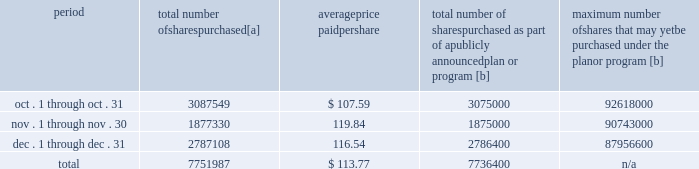Five-year performance comparison 2013 the following graph provides an indicator of cumulative total shareholder returns for the corporation as compared to the peer group index ( described above ) , the dj trans , and the s&p 500 .
The graph assumes that $ 100 was invested in the common stock of union pacific corporation and each index on december 31 , 2009 and that all dividends were reinvested .
The information below is historical in nature and is not necessarily indicative of future performance .
Purchases of equity securities 2013 during 2014 , we repurchased 33035204 shares of our common stock at an average price of $ 100.24 .
The table presents common stock repurchases during each month for the fourth quarter of 2014 : period total number of shares purchased [a] average price paid per share total number of shares purchased as part of a publicly announced plan or program [b] maximum number of shares that may yet be purchased under the plan or program [b] .
[a] total number of shares purchased during the quarter includes approximately 15587 shares delivered or attested to upc by employees to pay stock option exercise prices , satisfy excess tax withholding obligations for stock option exercises or vesting of retention units , and pay withholding obligations for vesting of retention shares .
[b] effective january 1 , 2014 , our board of directors authorized the repurchase of up to 120 million shares of our common stock by december 31 , 2017 .
These repurchases may be made on the open market or through other transactions .
Our management has sole discretion with respect to determining the timing and amount of these transactions. .
What percent of the share repurchases were in the fourth quarter? 
Computations: (7751987 / 33035204)
Answer: 0.23466. Five-year performance comparison 2013 the following graph provides an indicator of cumulative total shareholder returns for the corporation as compared to the peer group index ( described above ) , the dj trans , and the s&p 500 .
The graph assumes that $ 100 was invested in the common stock of union pacific corporation and each index on december 31 , 2009 and that all dividends were reinvested .
The information below is historical in nature and is not necessarily indicative of future performance .
Purchases of equity securities 2013 during 2014 , we repurchased 33035204 shares of our common stock at an average price of $ 100.24 .
The table presents common stock repurchases during each month for the fourth quarter of 2014 : period total number of shares purchased [a] average price paid per share total number of shares purchased as part of a publicly announced plan or program [b] maximum number of shares that may yet be purchased under the plan or program [b] .
[a] total number of shares purchased during the quarter includes approximately 15587 shares delivered or attested to upc by employees to pay stock option exercise prices , satisfy excess tax withholding obligations for stock option exercises or vesting of retention units , and pay withholding obligations for vesting of retention shares .
[b] effective january 1 , 2014 , our board of directors authorized the repurchase of up to 120 million shares of our common stock by december 31 , 2017 .
These repurchases may be made on the open market or through other transactions .
Our management has sole discretion with respect to determining the timing and amount of these transactions. .
What percentage of total number of shares purchased were purchased in december? 
Computations: (2787108 / 7751987)
Answer: 0.35953. 